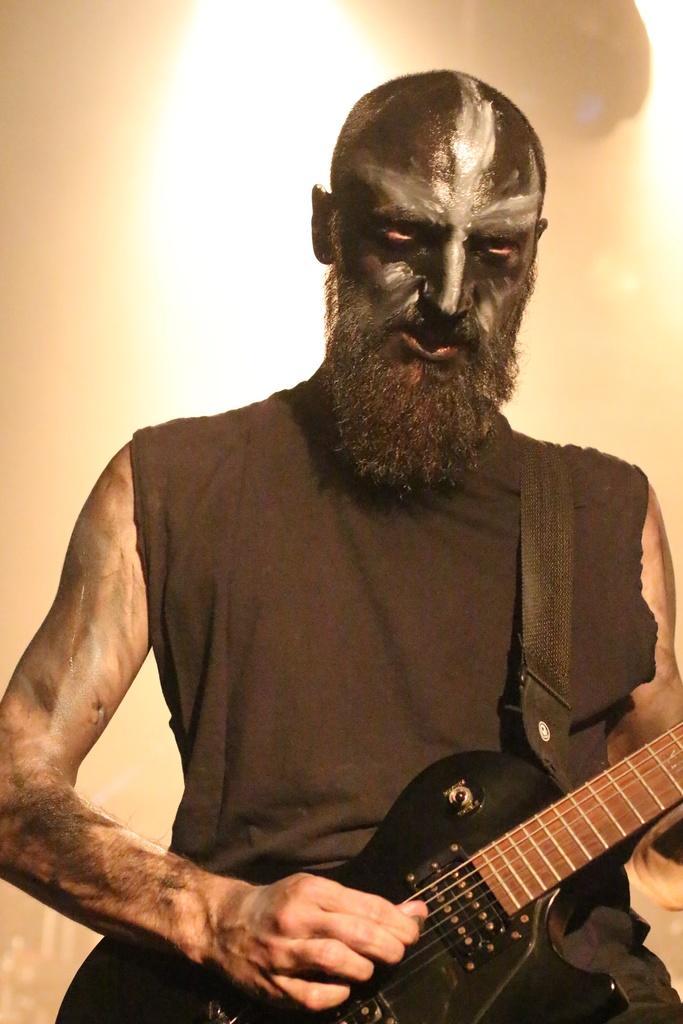Could you give a brief overview of what you see in this image? In the image we can see there is a man who is standing and holding guitar in his hand. 